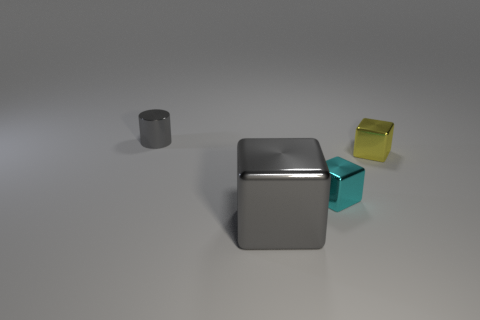Add 4 large red objects. How many objects exist? 8 Subtract all cylinders. How many objects are left? 3 Subtract all blue objects. Subtract all tiny metal cubes. How many objects are left? 2 Add 2 tiny gray metal cylinders. How many tiny gray metal cylinders are left? 3 Add 1 large gray shiny cubes. How many large gray shiny cubes exist? 2 Subtract 1 gray cylinders. How many objects are left? 3 